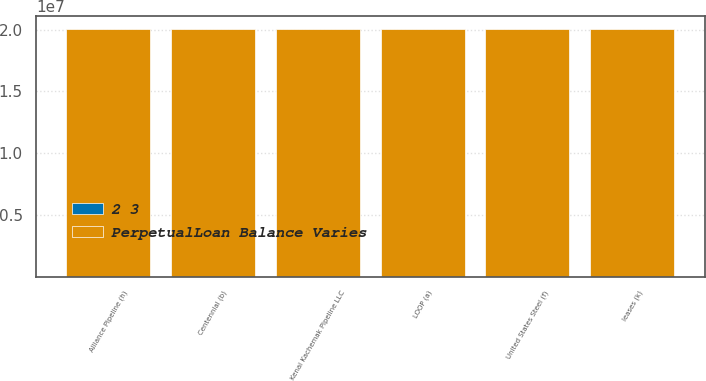Convert chart. <chart><loc_0><loc_0><loc_500><loc_500><stacked_bar_chart><ecel><fcel>LOOP (a)<fcel>Centennial (b)<fcel>United States Steel (f)<fcel>Alliance Pipeline (h)<fcel>Kenai Kachemak Pipeline LLC<fcel>leases (k)<nl><fcel>PerpetualLoan Balance Varies<fcel>2.0052e+07<fcel>2.0072e+07<fcel>2.0052e+07<fcel>2.0052e+07<fcel>2.0052e+07<fcel>2.0052e+07<nl><fcel>2 3<fcel>160<fcel>75<fcel>634<fcel>67<fcel>15<fcel>6<nl></chart> 